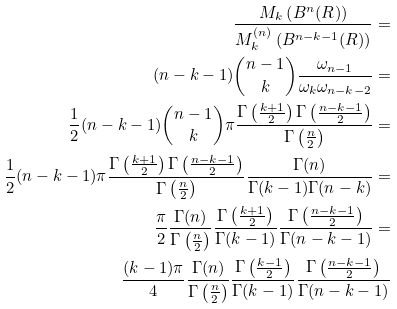Convert formula to latex. <formula><loc_0><loc_0><loc_500><loc_500>\frac { M _ { k } \left ( B ^ { n } ( R ) \right ) } { M _ { k } ^ { ( n ) } \left ( B ^ { n - k - 1 } ( R ) \right ) } = \\ ( n - k - 1 ) \binom { n - 1 } { k } \frac { \omega _ { n - 1 } } { \omega _ { k } \omega _ { n - k - 2 } } = \\ \frac { 1 } { 2 } ( n - k - 1 ) \binom { n - 1 } { k } \pi \frac { \Gamma \left ( \frac { k + 1 } 2 \right ) \Gamma \left ( \frac { n - k - 1 } 2 \right ) } { \Gamma \left ( \frac { n } 2 \right ) } = \\ \frac { 1 } { 2 } ( n - k - 1 ) \pi \frac { \Gamma \left ( \frac { k + 1 } 2 \right ) \Gamma \left ( \frac { n - k - 1 } 2 \right ) } { \Gamma \left ( \frac { n } 2 \right ) } \frac { \Gamma ( n ) } { \Gamma ( k - 1 ) \Gamma ( n - k ) } = \\ \frac { \pi } 2 \frac { \Gamma ( n ) } { \Gamma \left ( \frac { n } 2 \right ) } \frac { \Gamma \left ( \frac { k + 1 } 2 \right ) } { \Gamma ( k - 1 ) } \frac { \Gamma \left ( \frac { n - k - 1 } 2 \right ) } { \Gamma ( n - k - 1 ) } = \\ \frac { ( k - 1 ) \pi } 4 \frac { \Gamma ( n ) } { \Gamma \left ( \frac { n } 2 \right ) } \frac { \Gamma \left ( \frac { k - 1 } 2 \right ) } { \Gamma ( k - 1 ) } \frac { \Gamma \left ( \frac { n - k - 1 } 2 \right ) } { \Gamma ( n - k - 1 ) }</formula> 